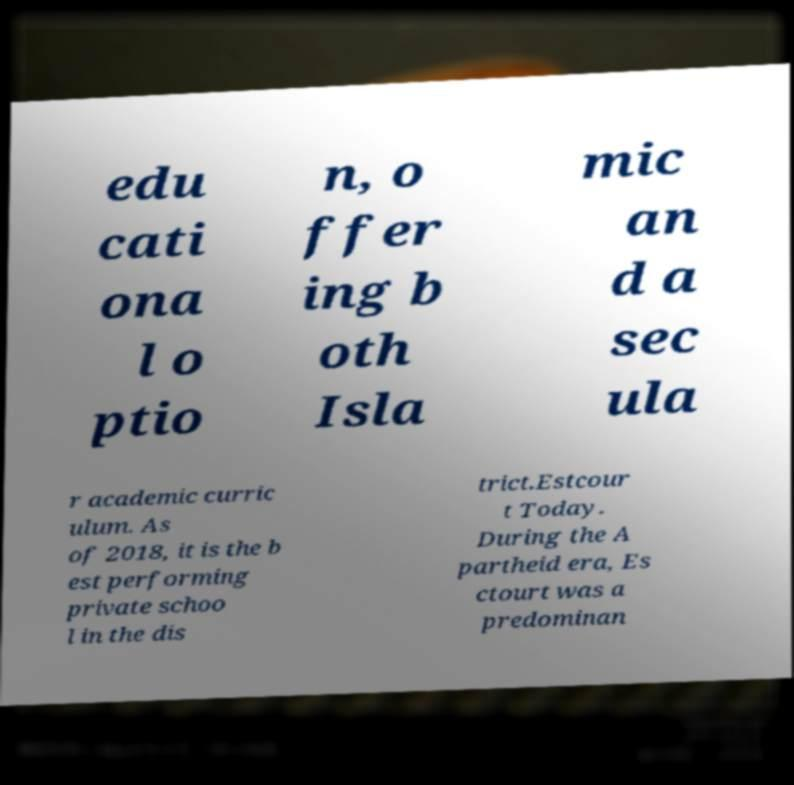Could you assist in decoding the text presented in this image and type it out clearly? edu cati ona l o ptio n, o ffer ing b oth Isla mic an d a sec ula r academic curric ulum. As of 2018, it is the b est performing private schoo l in the dis trict.Estcour t Today. During the A partheid era, Es ctourt was a predominan 